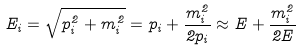<formula> <loc_0><loc_0><loc_500><loc_500>E _ { i } = \sqrt { p _ { i } ^ { 2 } + m _ { i } ^ { 2 } } = p _ { i } + \frac { m _ { i } ^ { 2 } } { 2 p _ { i } } \approx E + \frac { m _ { i } ^ { 2 } } { 2 E }</formula> 